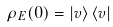Convert formula to latex. <formula><loc_0><loc_0><loc_500><loc_500>\rho _ { E } ( 0 ) = \left | v \right \rangle \left \langle v \right |</formula> 